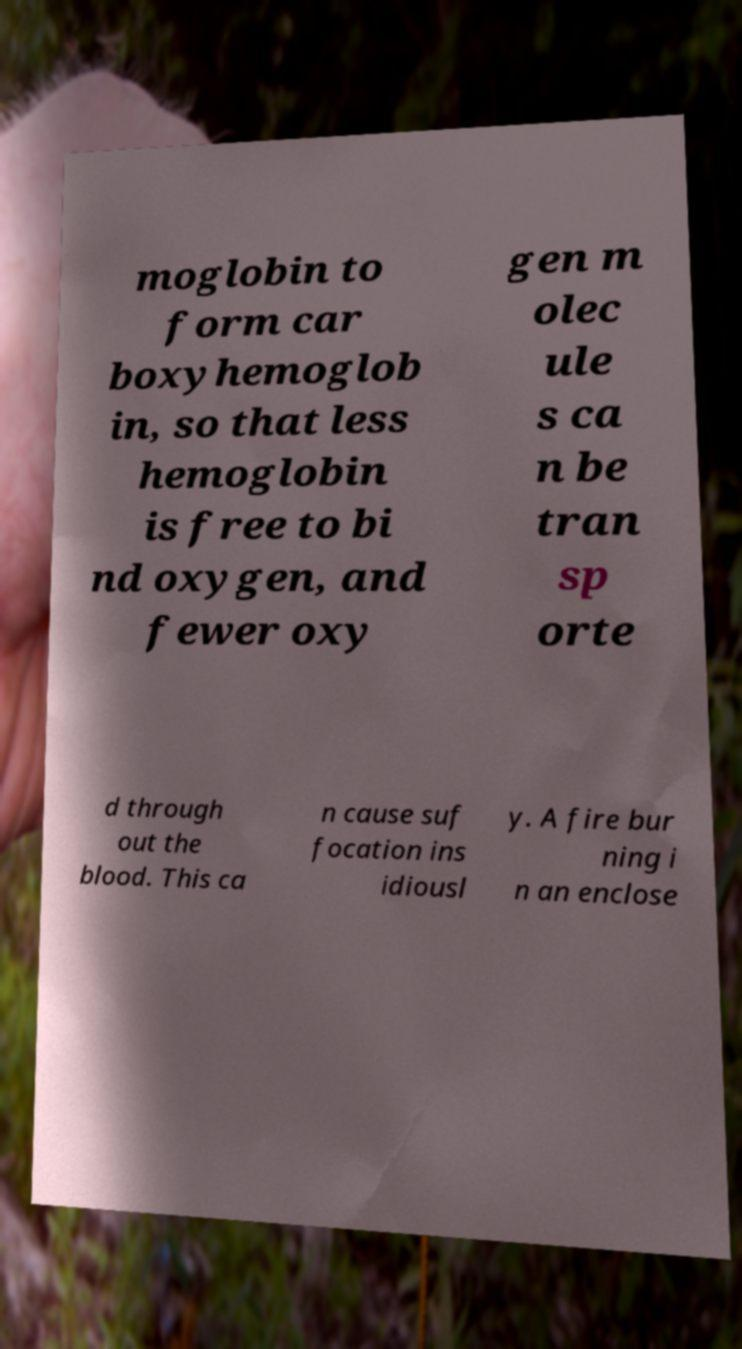Can you accurately transcribe the text from the provided image for me? moglobin to form car boxyhemoglob in, so that less hemoglobin is free to bi nd oxygen, and fewer oxy gen m olec ule s ca n be tran sp orte d through out the blood. This ca n cause suf focation ins idiousl y. A fire bur ning i n an enclose 